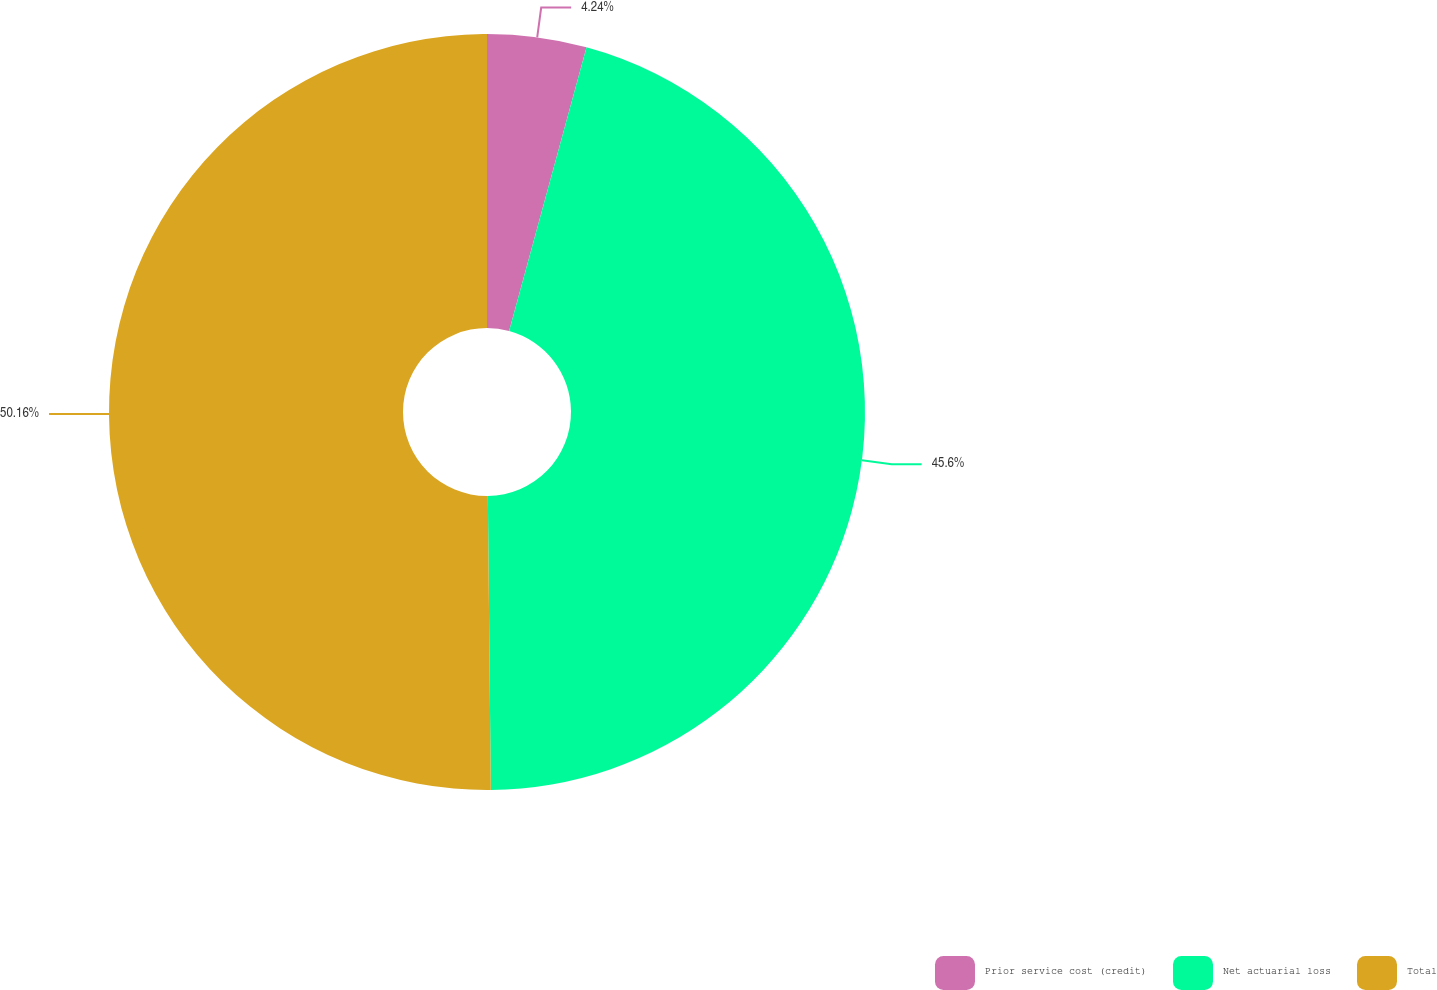Convert chart. <chart><loc_0><loc_0><loc_500><loc_500><pie_chart><fcel>Prior service cost (credit)<fcel>Net actuarial loss<fcel>Total<nl><fcel>4.24%<fcel>45.6%<fcel>50.16%<nl></chart> 